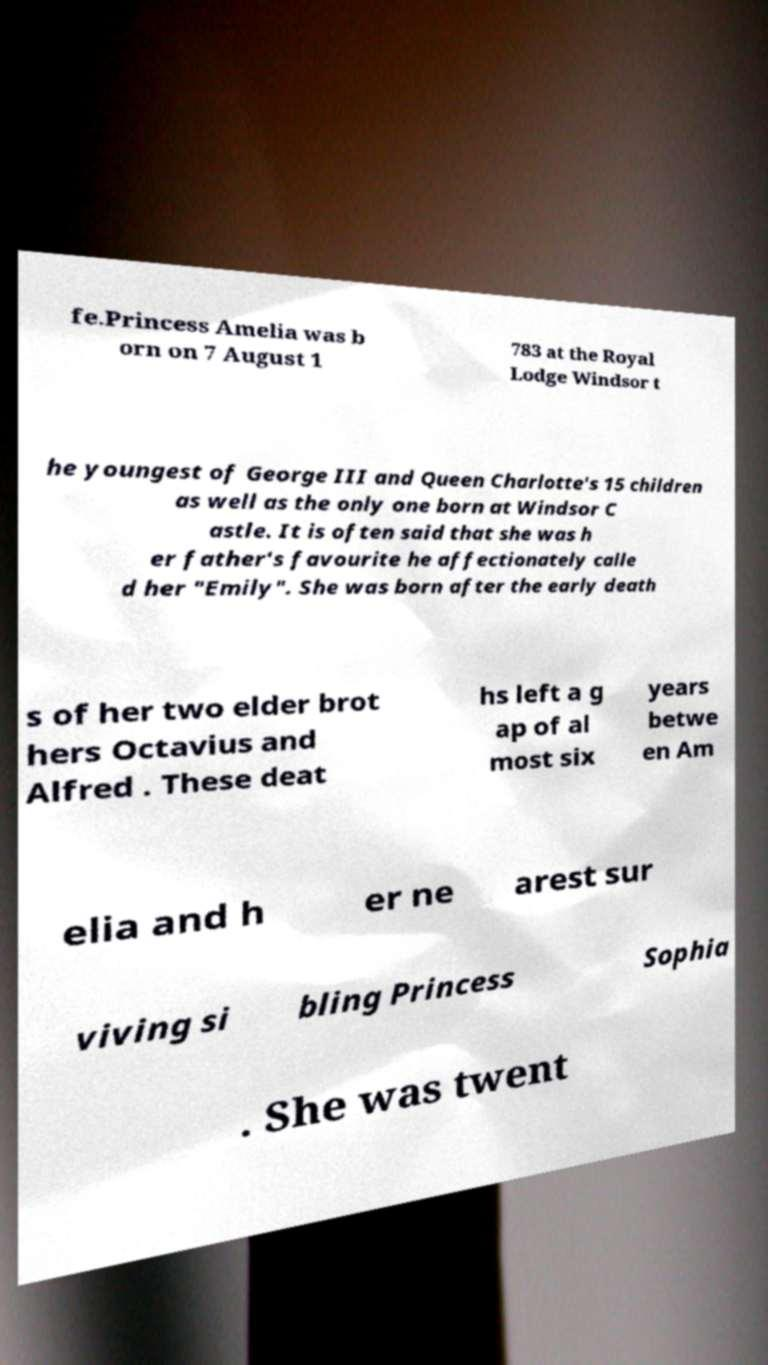Please read and relay the text visible in this image. What does it say? fe.Princess Amelia was b orn on 7 August 1 783 at the Royal Lodge Windsor t he youngest of George III and Queen Charlotte's 15 children as well as the only one born at Windsor C astle. It is often said that she was h er father's favourite he affectionately calle d her "Emily". She was born after the early death s of her two elder brot hers Octavius and Alfred . These deat hs left a g ap of al most six years betwe en Am elia and h er ne arest sur viving si bling Princess Sophia . She was twent 